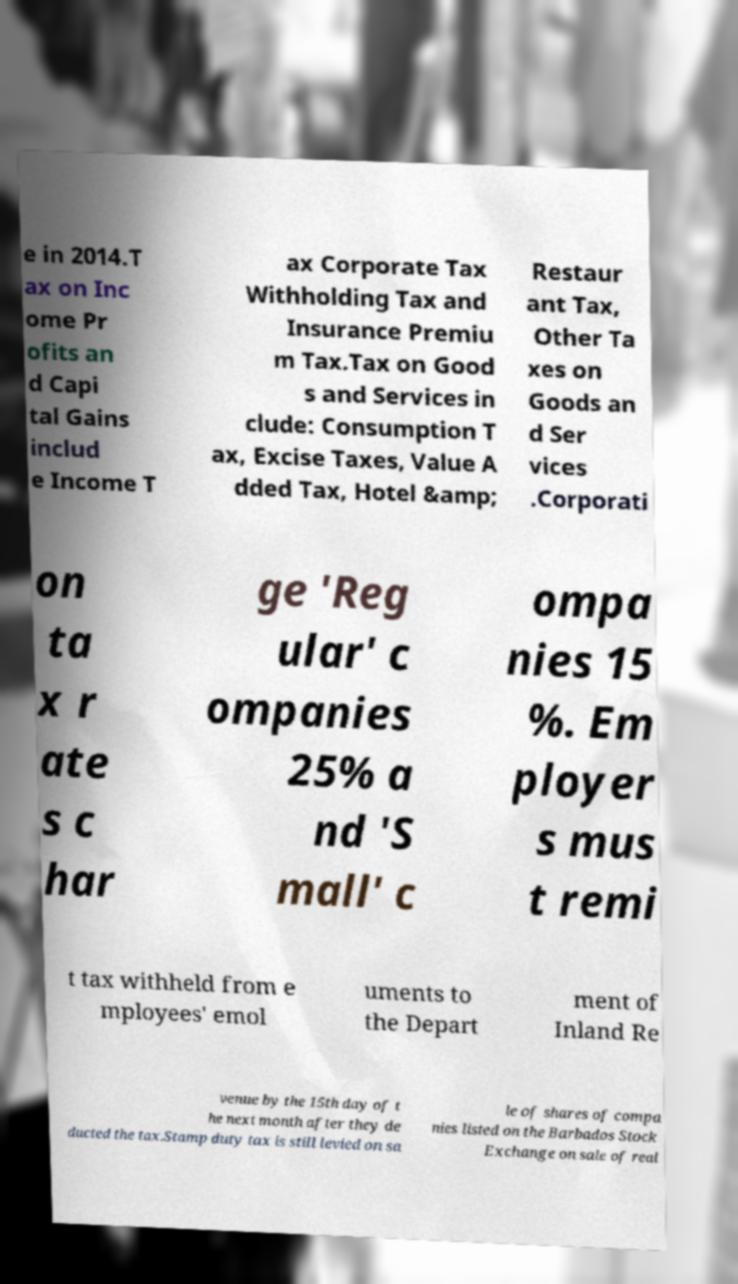There's text embedded in this image that I need extracted. Can you transcribe it verbatim? e in 2014.T ax on Inc ome Pr ofits an d Capi tal Gains includ e Income T ax Corporate Tax Withholding Tax and Insurance Premiu m Tax.Tax on Good s and Services in clude: Consumption T ax, Excise Taxes, Value A dded Tax, Hotel &amp; Restaur ant Tax, Other Ta xes on Goods an d Ser vices .Corporati on ta x r ate s c har ge 'Reg ular' c ompanies 25% a nd 'S mall' c ompa nies 15 %. Em ployer s mus t remi t tax withheld from e mployees' emol uments to the Depart ment of Inland Re venue by the 15th day of t he next month after they de ducted the tax.Stamp duty tax is still levied on sa le of shares of compa nies listed on the Barbados Stock Exchange on sale of real 